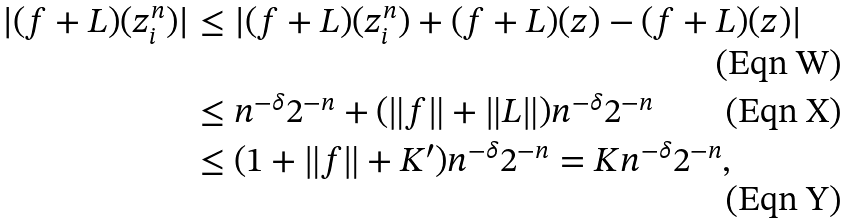<formula> <loc_0><loc_0><loc_500><loc_500>| ( f + L ) ( z ^ { n } _ { i } ) | & \leq | ( f + L ) ( z ^ { n } _ { i } ) + ( f + L ) ( z ) - ( f + L ) ( z ) | \\ & \leq n ^ { - \delta } 2 ^ { - n } + ( \| f \| + \| L \| ) n ^ { - \delta } 2 ^ { - n } \\ & \leq ( 1 + \| f \| + K ^ { \prime } ) n ^ { - \delta } 2 ^ { - n } = K n ^ { - \delta } 2 ^ { - n } ,</formula> 